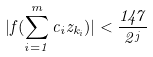Convert formula to latex. <formula><loc_0><loc_0><loc_500><loc_500>| f ( \sum _ { i = 1 } ^ { m } c _ { i } z _ { k _ { i } } ) | < \frac { 1 4 7 } { 2 ^ { j } }</formula> 